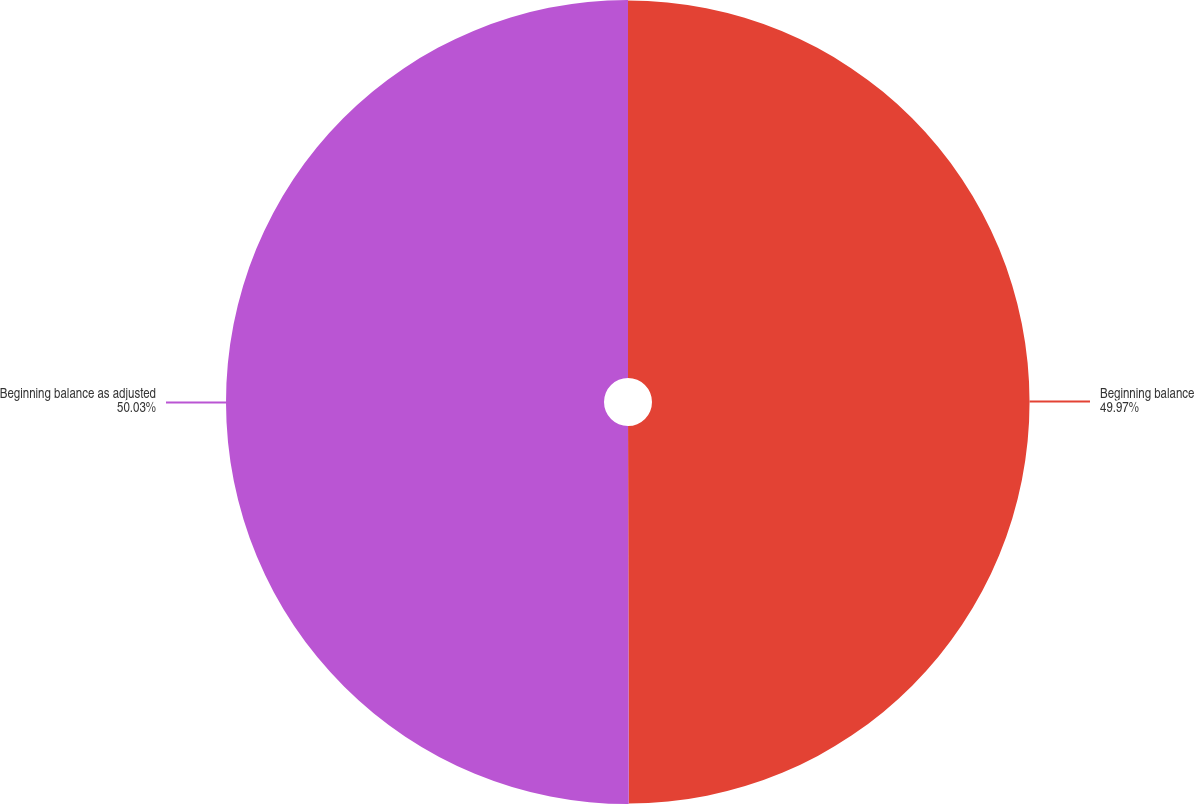Convert chart. <chart><loc_0><loc_0><loc_500><loc_500><pie_chart><fcel>Beginning balance<fcel>Beginning balance as adjusted<nl><fcel>49.97%<fcel>50.03%<nl></chart> 